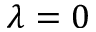Convert formula to latex. <formula><loc_0><loc_0><loc_500><loc_500>\lambda = 0</formula> 